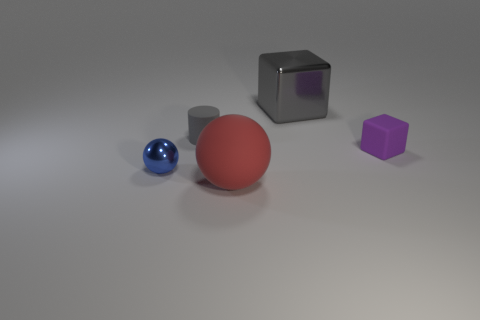Add 2 small purple matte blocks. How many objects exist? 7 Subtract all cubes. How many objects are left? 3 Subtract all gray cubes. Subtract all red cylinders. How many cubes are left? 1 Subtract all gray shiny cylinders. Subtract all large gray objects. How many objects are left? 4 Add 2 small purple matte blocks. How many small purple matte blocks are left? 3 Add 3 big blue rubber things. How many big blue rubber things exist? 3 Subtract 1 blue spheres. How many objects are left? 4 Subtract 2 balls. How many balls are left? 0 